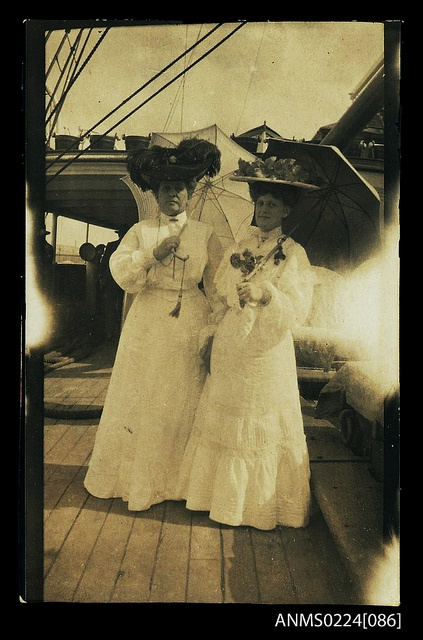Describe the objects in this image and their specific colors. I can see people in black and tan tones, people in black, tan, and olive tones, umbrella in black, darkgreen, tan, and gray tones, umbrella in black, tan, and olive tones, and potted plant in black, darkgreen, gray, and tan tones in this image. 